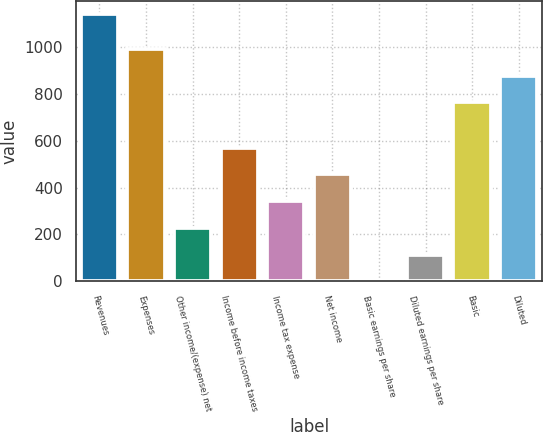Convert chart to OTSL. <chart><loc_0><loc_0><loc_500><loc_500><bar_chart><fcel>Revenues<fcel>Expenses<fcel>Other income/(expense) net<fcel>Income before income taxes<fcel>Income tax expense<fcel>Net income<fcel>Basic earnings per share<fcel>Diluted earnings per share<fcel>Basic<fcel>Diluted<nl><fcel>1140.4<fcel>991.92<fcel>228.36<fcel>570.39<fcel>342.37<fcel>456.38<fcel>0.34<fcel>114.35<fcel>763.9<fcel>877.91<nl></chart> 